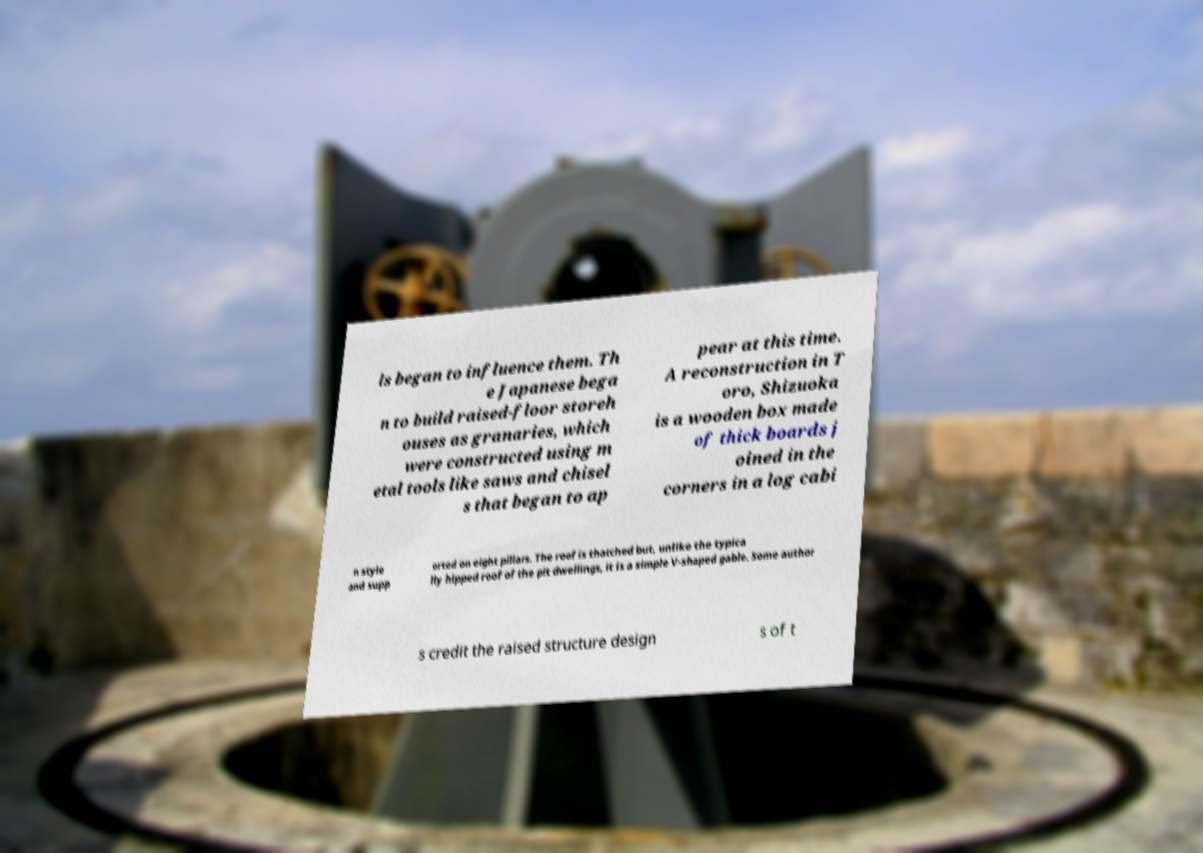Can you accurately transcribe the text from the provided image for me? ls began to influence them. Th e Japanese bega n to build raised-floor storeh ouses as granaries, which were constructed using m etal tools like saws and chisel s that began to ap pear at this time. A reconstruction in T oro, Shizuoka is a wooden box made of thick boards j oined in the corners in a log cabi n style and supp orted on eight pillars. The roof is thatched but, unlike the typica lly hipped roof of the pit dwellings, it is a simple V-shaped gable. Some author s credit the raised structure design s of t 